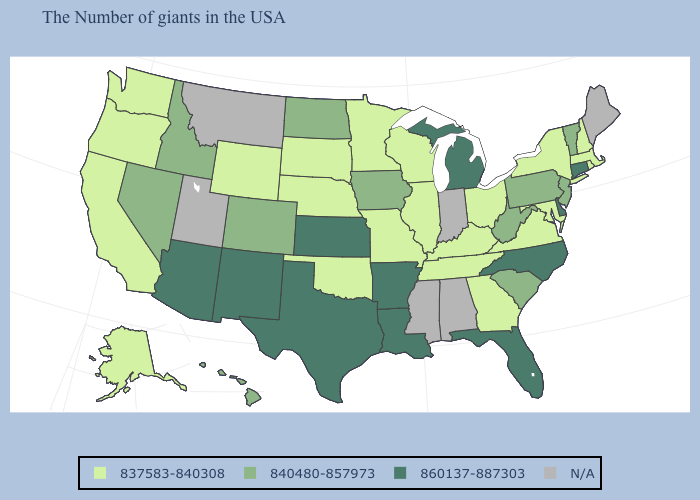Among the states that border Minnesota , which have the lowest value?
Short answer required. Wisconsin, South Dakota. What is the value of Texas?
Short answer required. 860137-887303. Does Missouri have the lowest value in the MidWest?
Keep it brief. Yes. Does Hawaii have the lowest value in the USA?
Give a very brief answer. No. Which states hav the highest value in the West?
Quick response, please. New Mexico, Arizona. Name the states that have a value in the range 837583-840308?
Short answer required. Massachusetts, Rhode Island, New Hampshire, New York, Maryland, Virginia, Ohio, Georgia, Kentucky, Tennessee, Wisconsin, Illinois, Missouri, Minnesota, Nebraska, Oklahoma, South Dakota, Wyoming, California, Washington, Oregon, Alaska. Which states have the highest value in the USA?
Keep it brief. Connecticut, Delaware, North Carolina, Florida, Michigan, Louisiana, Arkansas, Kansas, Texas, New Mexico, Arizona. Name the states that have a value in the range N/A?
Give a very brief answer. Maine, Indiana, Alabama, Mississippi, Utah, Montana. What is the lowest value in the USA?
Keep it brief. 837583-840308. What is the value of Florida?
Be succinct. 860137-887303. What is the value of South Carolina?
Short answer required. 840480-857973. What is the value of Missouri?
Keep it brief. 837583-840308. Which states hav the highest value in the South?
Write a very short answer. Delaware, North Carolina, Florida, Louisiana, Arkansas, Texas. 